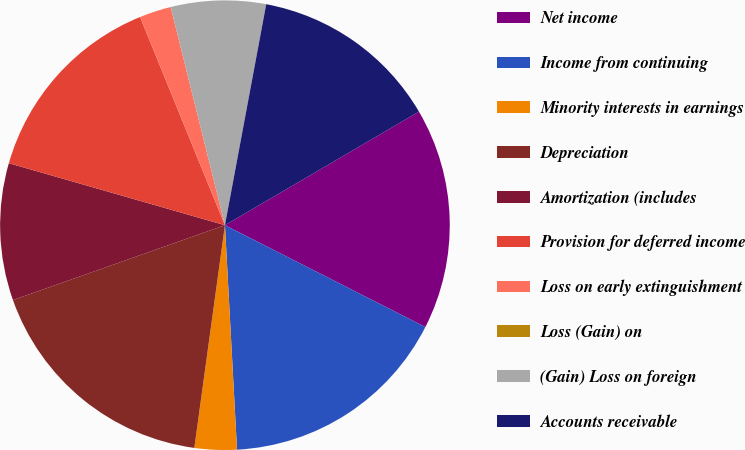Convert chart to OTSL. <chart><loc_0><loc_0><loc_500><loc_500><pie_chart><fcel>Net income<fcel>Income from continuing<fcel>Minority interests in earnings<fcel>Depreciation<fcel>Amortization (includes<fcel>Provision for deferred income<fcel>Loss on early extinguishment<fcel>Loss (Gain) on<fcel>(Gain) Loss on foreign<fcel>Accounts receivable<nl><fcel>15.91%<fcel>16.66%<fcel>3.03%<fcel>17.42%<fcel>9.85%<fcel>14.39%<fcel>2.28%<fcel>0.0%<fcel>6.82%<fcel>13.63%<nl></chart> 